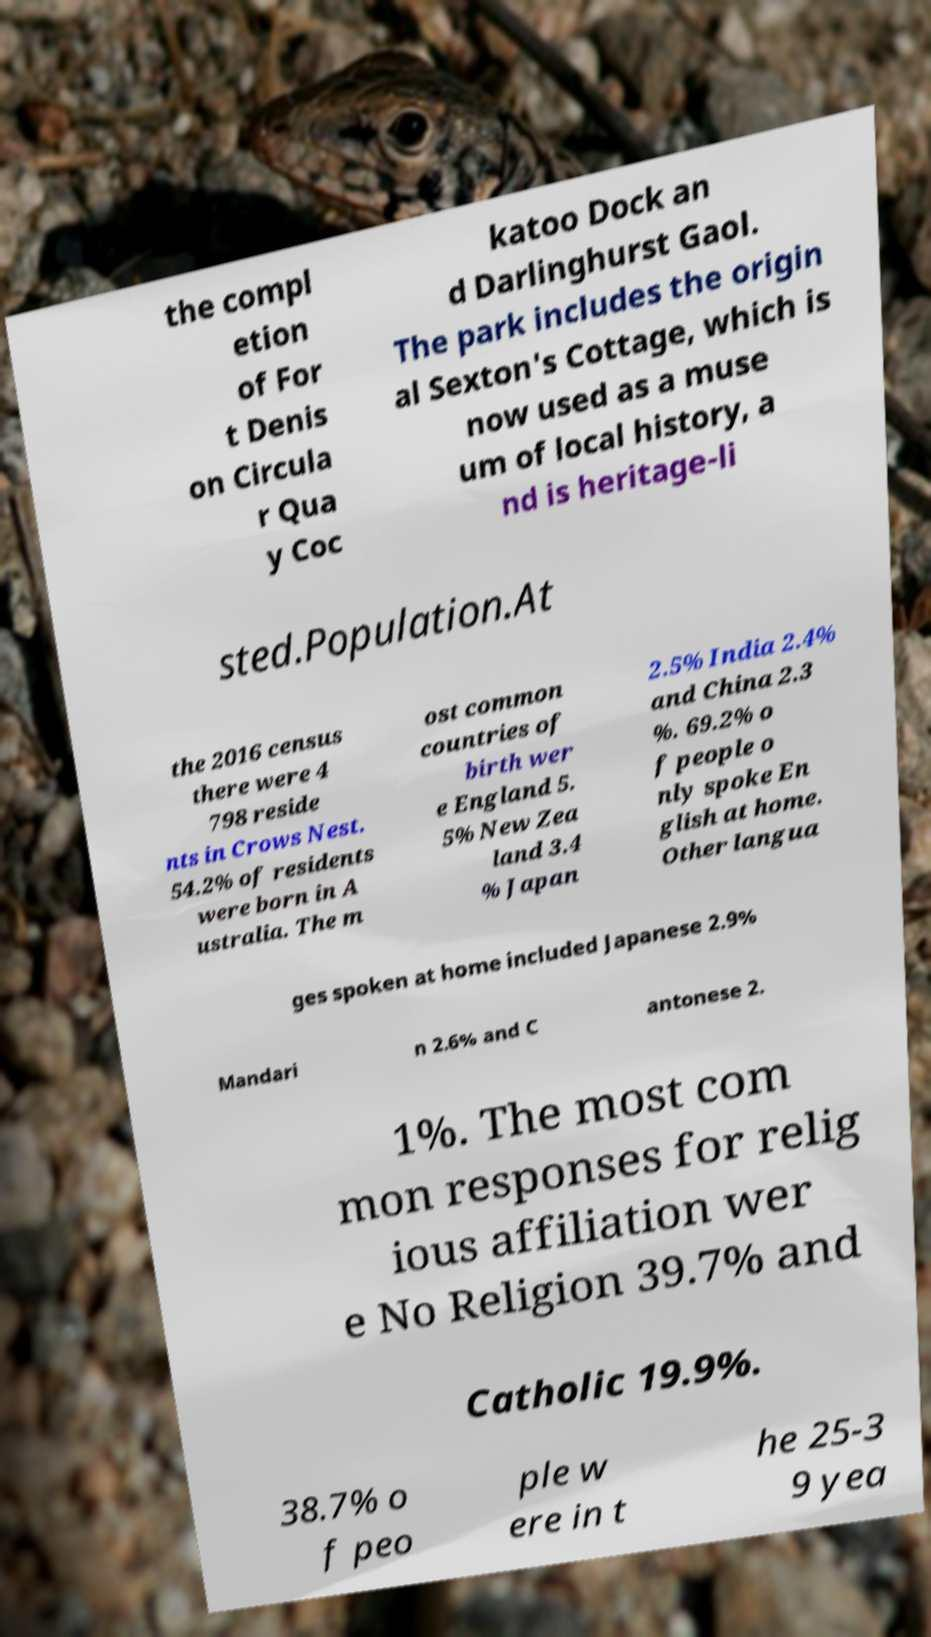Could you extract and type out the text from this image? the compl etion of For t Denis on Circula r Qua y Coc katoo Dock an d Darlinghurst Gaol. The park includes the origin al Sexton's Cottage, which is now used as a muse um of local history, a nd is heritage-li sted.Population.At the 2016 census there were 4 798 reside nts in Crows Nest. 54.2% of residents were born in A ustralia. The m ost common countries of birth wer e England 5. 5% New Zea land 3.4 % Japan 2.5% India 2.4% and China 2.3 %. 69.2% o f people o nly spoke En glish at home. Other langua ges spoken at home included Japanese 2.9% Mandari n 2.6% and C antonese 2. 1%. The most com mon responses for relig ious affiliation wer e No Religion 39.7% and Catholic 19.9%. 38.7% o f peo ple w ere in t he 25-3 9 yea 